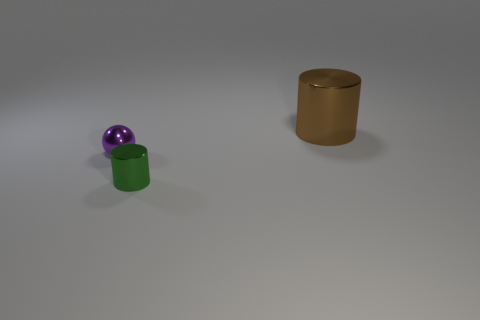Add 3 large purple things. How many objects exist? 6 Subtract all cylinders. How many objects are left? 1 Subtract all tiny green shiny cylinders. Subtract all tiny purple balls. How many objects are left? 1 Add 2 green cylinders. How many green cylinders are left? 3 Add 3 brown metallic things. How many brown metallic things exist? 4 Subtract 1 green cylinders. How many objects are left? 2 